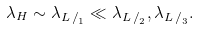Convert formula to latex. <formula><loc_0><loc_0><loc_500><loc_500>\lambda _ { H } \sim \lambda _ { { L \, / } _ { 1 } } \ll \lambda _ { { L \, / } _ { 2 } } , \lambda _ { { L \, / } _ { 3 } } .</formula> 